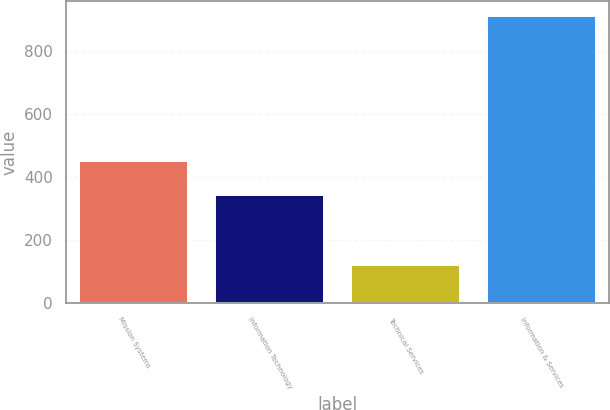<chart> <loc_0><loc_0><loc_500><loc_500><bar_chart><fcel>Mission Systems<fcel>Information Technology<fcel>Technical Services<fcel>Information & Services<nl><fcel>451<fcel>342<fcel>120<fcel>913<nl></chart> 